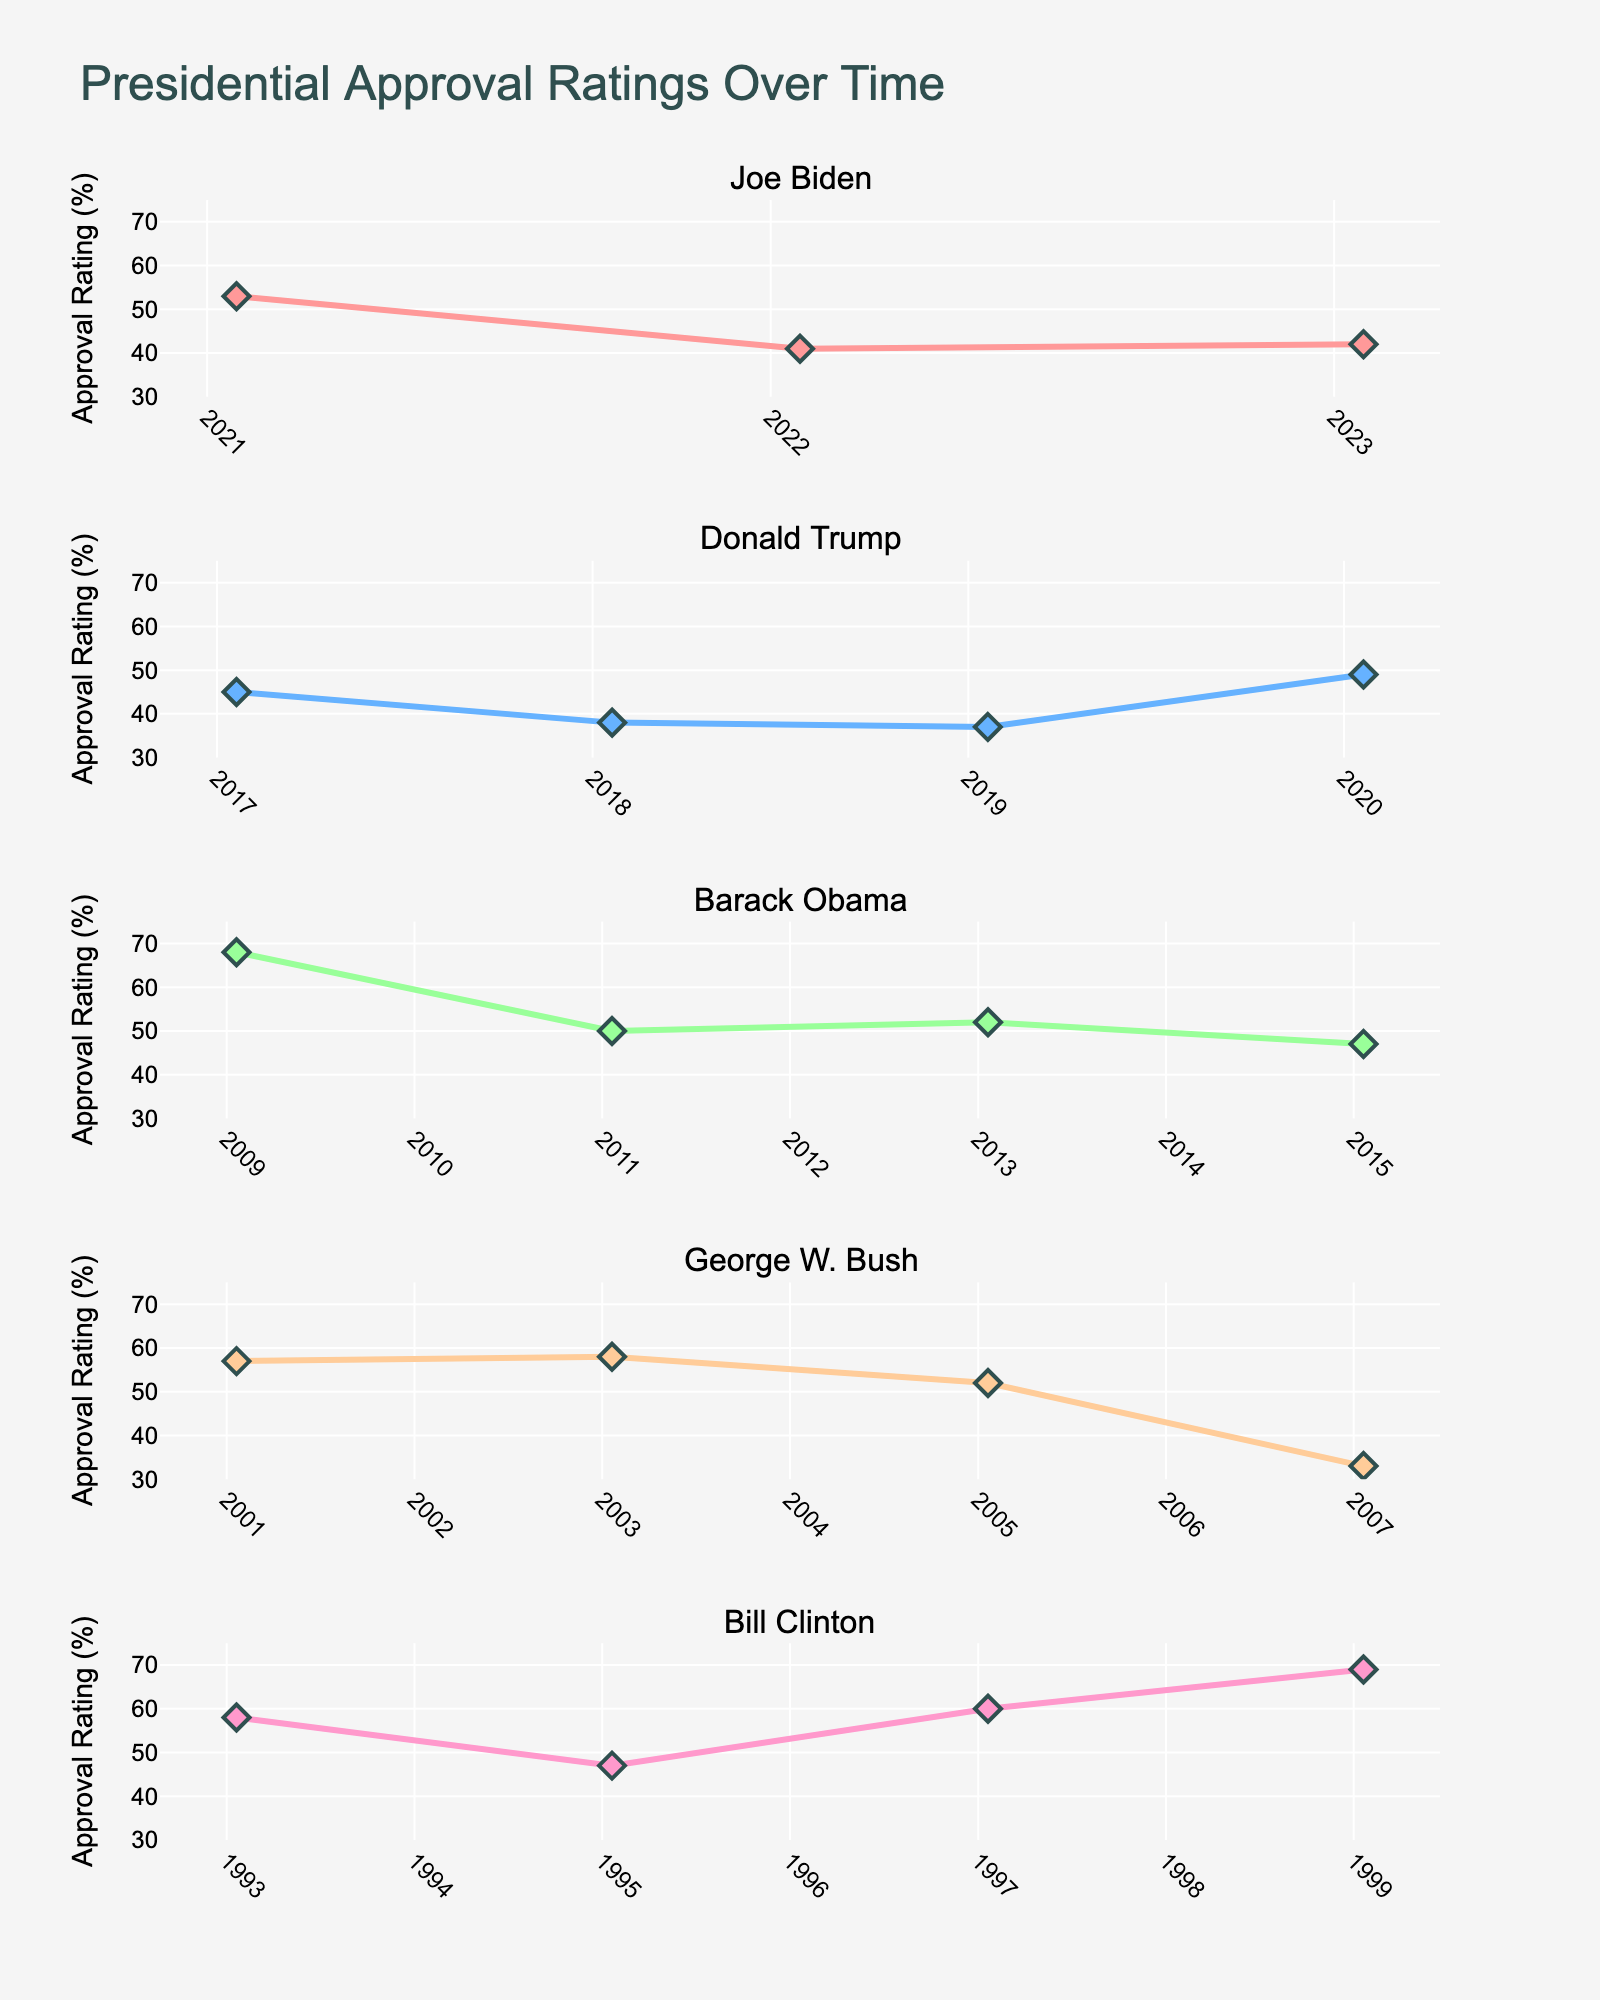What's the title of the figure? The title is centered at the top of the figure and provides an overview of the content shown. The title of the figure is "Presidential Approval Ratings Over Time".
Answer: Presidential Approval Ratings Over Time Which president has the highest approval rating at any point in time? According to the visual information provided, the highest approval rating across all the subplots is for Barack Obama, who has an approval rating of 68%. This can be seen at the start of his term in 2009.
Answer: Barack Obama How did George W. Bush's approval rating change over time? To answer this, observe the trend line in George W. Bush's subplot. His approval rating starts at 57%, rises slightly to 58%, then drops to 52%, and finally falls significantly to 33%.
Answer: It decreased What is the range of approval ratings Joe Biden has had according to the figure? To determine the range, identify the highest and lowest values from Joe Biden's subplot. He starts with 53%, drops to 41%, and ends at 42%. Therefore, the range is 53% to 41%.
Answer: 41% to 53% Which president's approval rating saw the largest increase within their term? To find the largest increase, compare the changes in approval ratings for each president. Donald Trump's approval rating increased from 37% to 49% between 2019 and 2020, a rise of 12%, which is the largest increase among the presidents shown.
Answer: Donald Trump How do Barack Obama's approval ratings compare between his first and second terms? Look at the data points for 2009, 2011, 2013, and 2015 in Obama’s subplot. 2009 and 2011 represent his first term with ratings of 68% and 50% respectively. 2013 and 2015 represent his second term with ratings of 52% and 47%. The comparison shows that his ratings slightly declined in the second term.
Answer: Slightly declined What time period does this figure cover? To determine the time period, note the earliest and latest dates on the x-axes across all subplots. The earliest date is 1993 for Bill Clinton, and the latest date is 2023 for Joe Biden. Therefore, the figure covers from 1993 to 2023.
Answer: 1993 to 2023 What trend do we observe in Bill Clinton's approval ratings from the first to the last data point? Observe Bill Clinton's subplot: his approval ratings start at 58% in 1993, drop to 47% by 1995, and then increase to 60% in 1997 and further to 69% in 1999. The overall trend shows an initial drop followed by a significant increase.
Answer: Initial drop followed by an increase Identify the year when George W. Bush had his lowest approval rating. Focus on George W. Bush's subplot and identify the lowest point on his approval rating line, which is at 33% in 2007.
Answer: 2007 Which president shows the most stable approval rating (the least variation) over the given term? By observing the smoothness of the lines and the data points' closeness, Joe Biden's subplot appears the most stable with minor variations between 41% to 53% compared to other presidents whose ratings show wider swings.
Answer: Joe Biden 